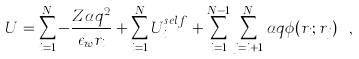Convert formula to latex. <formula><loc_0><loc_0><loc_500><loc_500>U = \sum _ { i = 1 } ^ { N } - \frac { Z \alpha q ^ { 2 } } { \epsilon _ { w } r _ { i } } + \sum _ { i = 1 } ^ { N } U _ { i } ^ { s e l f } + \sum _ { i = 1 } ^ { N - 1 } \sum _ { j = i + 1 } ^ { N } \alpha q \phi ( { r } _ { i } ; { r } _ { j } ) \ ,</formula> 